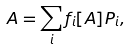<formula> <loc_0><loc_0><loc_500><loc_500>A = \sum _ { i } f _ { i } [ A ] P _ { i } ,</formula> 